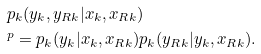Convert formula to latex. <formula><loc_0><loc_0><loc_500><loc_500>& p _ { k } ( y _ { k } , y _ { R k } | x _ { k } , x _ { R k } ) \\ & ^ { p } = p _ { k } ( y _ { k } | x _ { k } , x _ { R k } ) p _ { k } ( y _ { R k } | y _ { k } , x _ { R k } ) .</formula> 